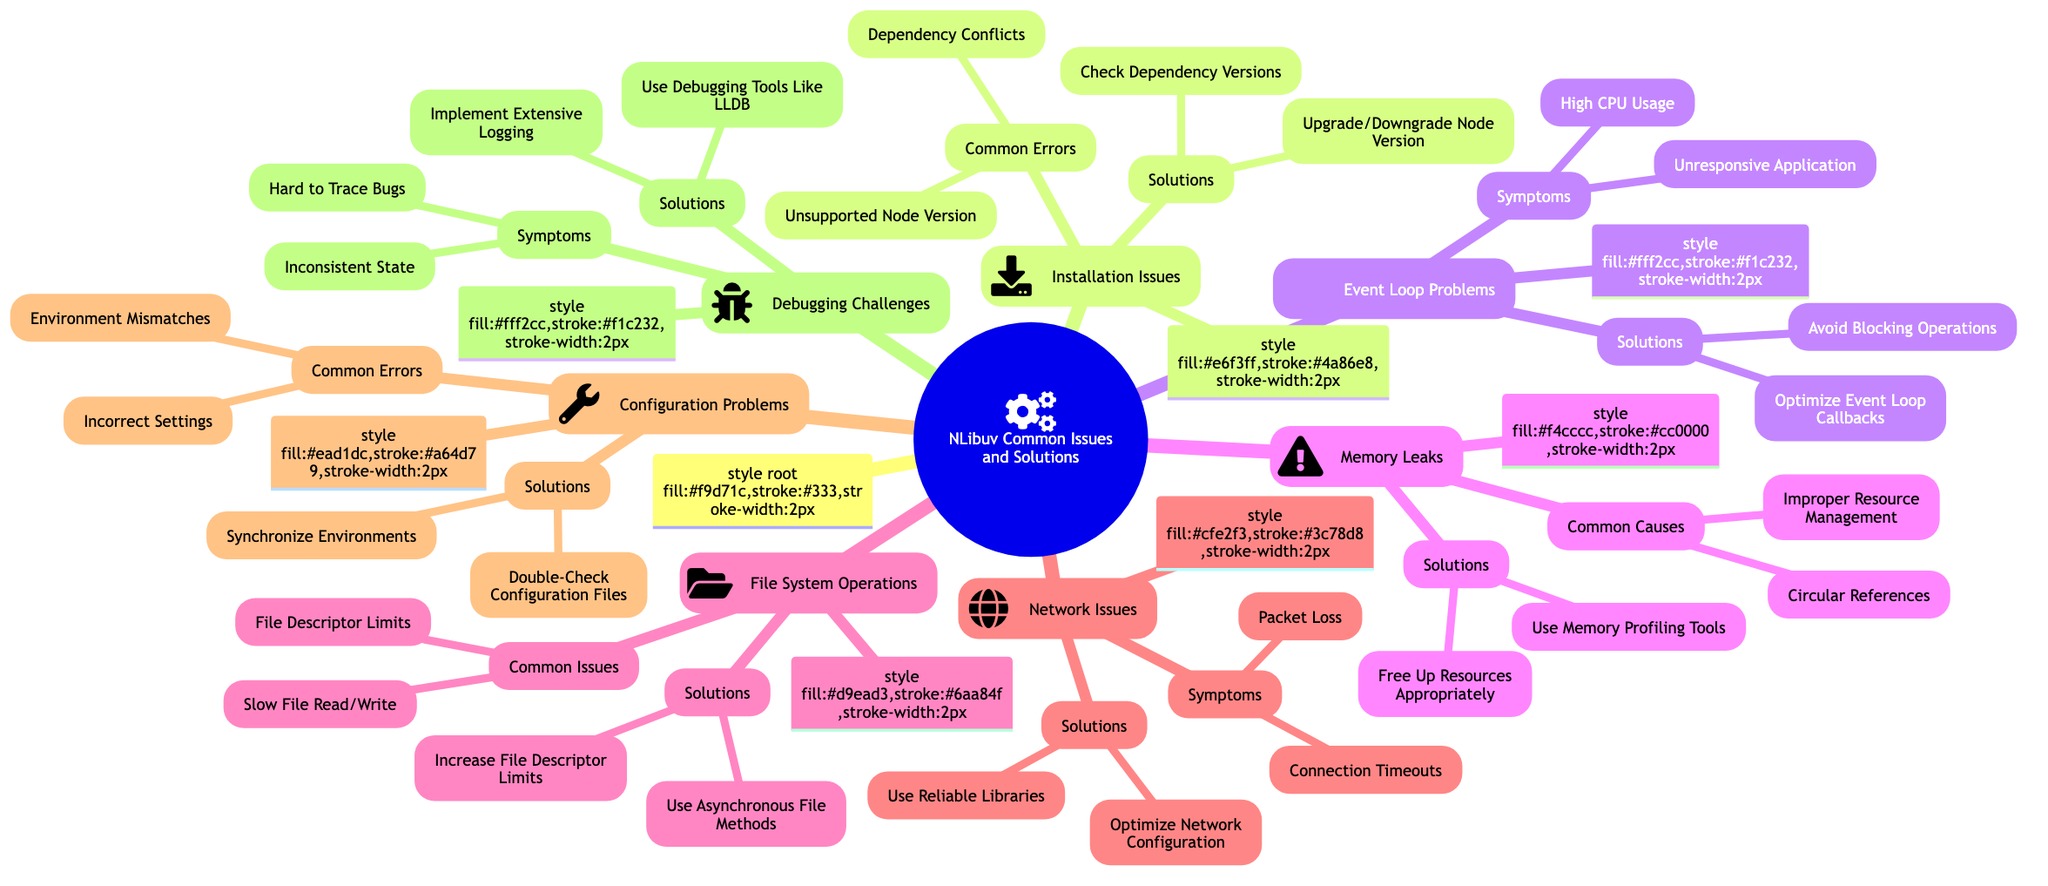What are the two common errors under Installation Issues? The "Installation Issues" node has a sub-node labeled "Common Errors," which lists "Dependency Conflicts" and "Unsupported Node Version."
Answer: Dependency Conflicts, Unsupported Node Version How many symptoms are listed under Event Loop Problems? The "Event Loop Problems" node contains a sub-node labeled "Symptoms," which lists two specific symptoms: "Unresponsive Application" and "High CPU Usage." Therefore, there are two symptoms in total.
Answer: 2 What is one solution provided for avoiding memory leaks? Under the "Memory Leaks" node, there is a sub-node labeled "Solutions" that contains the entry "Free Up Resources Appropriately," which addresses how to manage resources better to avoid memory leaks.
Answer: Free Up Resources Appropriately What type of configuration problem is mentioned in the diagram? The "Configuration Problems" node includes a sub-node labeled "Common Errors," which lists potential issues such as "Incorrect Settings" and "Environment Mismatches," indicating the types of common configuration problems.
Answer: Incorrect Settings, Environment Mismatches Which problems can lead to high CPU usage according to the diagram? The "Event Loop Problems" node lists "High CPU Usage" as one of the symptoms. Further, in the solutions, it suggests "Optimize Event Loop Callbacks," indicating that inefficient handling of callbacks can lead to high CPU usage.
Answer: High CPU Usage What can be done to improve file system performance? Under the "File System Operations" node, there is a sub-node labeled "Solutions," which includes "Use Asynchronous File Methods" and "Increase File Descriptor Limits," both of which can improve file system performance.
Answer: Use Asynchronous File Methods, Increase File Descriptor Limits How many solutions are provided for debugging challenges? The "Debugging Challenges" node includes a sub-node labeled "Solutions" that lists two specific solutions: "Use Debugging Tools Like LLDB" and "Implement Extensive Logging." Thus, there are two solutions in total for debugging challenges.
Answer: 2 What is a symptom listed under Network Issues? The "Network Issues" node contains a sub-node labeled "Symptoms," where it states "Connection Timeouts" and "Packet Loss" are symptoms, indicating network-related problems users may face.
Answer: Connection Timeouts, Packet Loss 